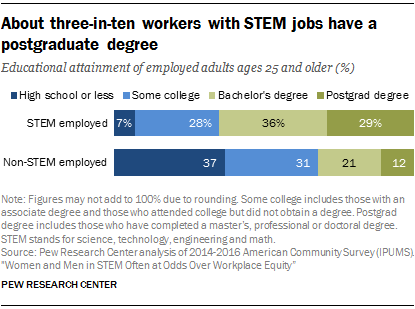Outline some significant characteristics in this image. The median of STEM-employed bars is greater than the median of non-STEM employed bars. According to data, 36% of individuals employed in STEM fields have a bachelor's degree or higher. 